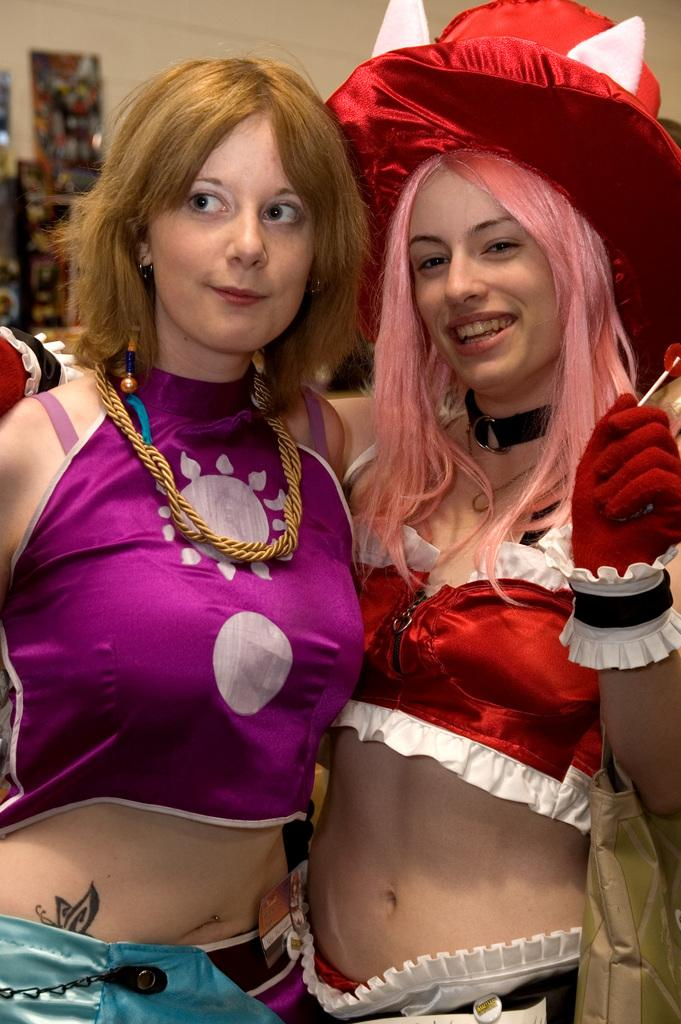What are the people in the image wearing? The people in the image are wearing costumes. Can you describe what one person is doing in the image? One person is holding an object in the image. What else can be seen on the person holding the object? The person holding the object is also wearing a bag. What can be seen in the background of the image? There is a wall and boards visible in the background of the image. What type of skin condition can be seen on the person holding the object in the image? There is no indication of a skin condition on the person holding the object in the image. Is there an umbrella visible in the image? No, there is no umbrella present in the image. 